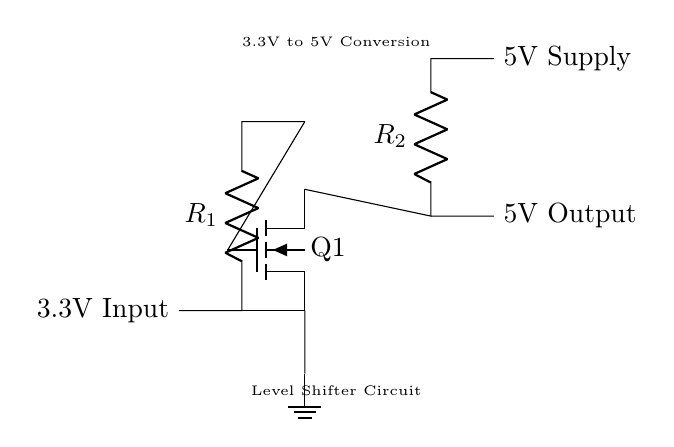What is the input voltage for this circuit? The input voltage is labeled as 3.3V, which is indicated at the left side of the circuit diagram.
Answer: 3.3V What type of transistor is used in the circuit? The circuit uses an N-channel MOSFET, which is represented by the symbol for Q1. This is confirmed by the designation "nfet" in the diagram.
Answer: N-channel MOSFET What is the purpose of resistor R1? Resistor R1 is connected to the input and contributes to the functioning of the circuit by limiting the current flowing into the gate of the MOSFET. This is essential for controlling the operation of the MOSFET.
Answer: Current limitation What is the output voltage of this level shifter? The output voltage is provided as 5V, which is specified at the right side of the circuit, connected to the output terminal.
Answer: 5V How many resistors are present in the circuit? There are two resistors, R1 and R2, indicated in the circuit diagram. They are essential components used in the level shifting process.
Answer: Two What is the role of the ground connection in this circuit? The ground connection provides a reference point for all the voltages in the circuit, ensuring proper operation of the MOSFET and stabilizing the circuit. It connects to the source of the MOSFET.
Answer: Reference point Why is there a need for a level shifter in a multi-standard system? A level shifter is necessary to enable communication between devices operating at different voltage levels (3.3V and 5V in this case), ensuring compatibility and functionality across different standards and devices.
Answer: Compatibility 